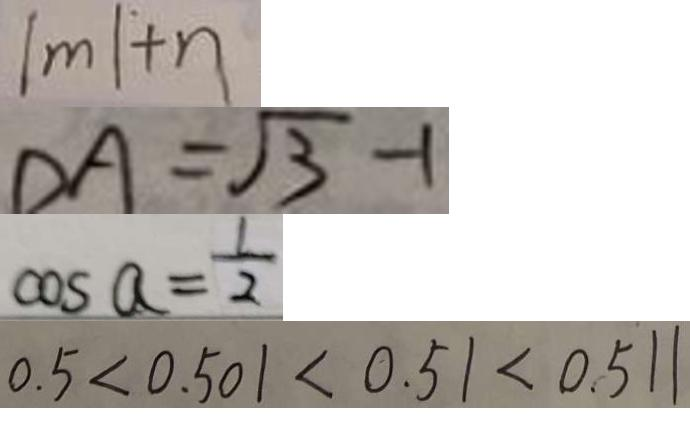Convert formula to latex. <formula><loc_0><loc_0><loc_500><loc_500>\vert m \vert + n 
 D A = \sqrt { 3 } - 1 
 \cos a = \frac { 1 } { 2 } 
 0 . 5 < 0 . 5 0 1 < 0 . 5 1 < 0 . 5 1 1</formula> 